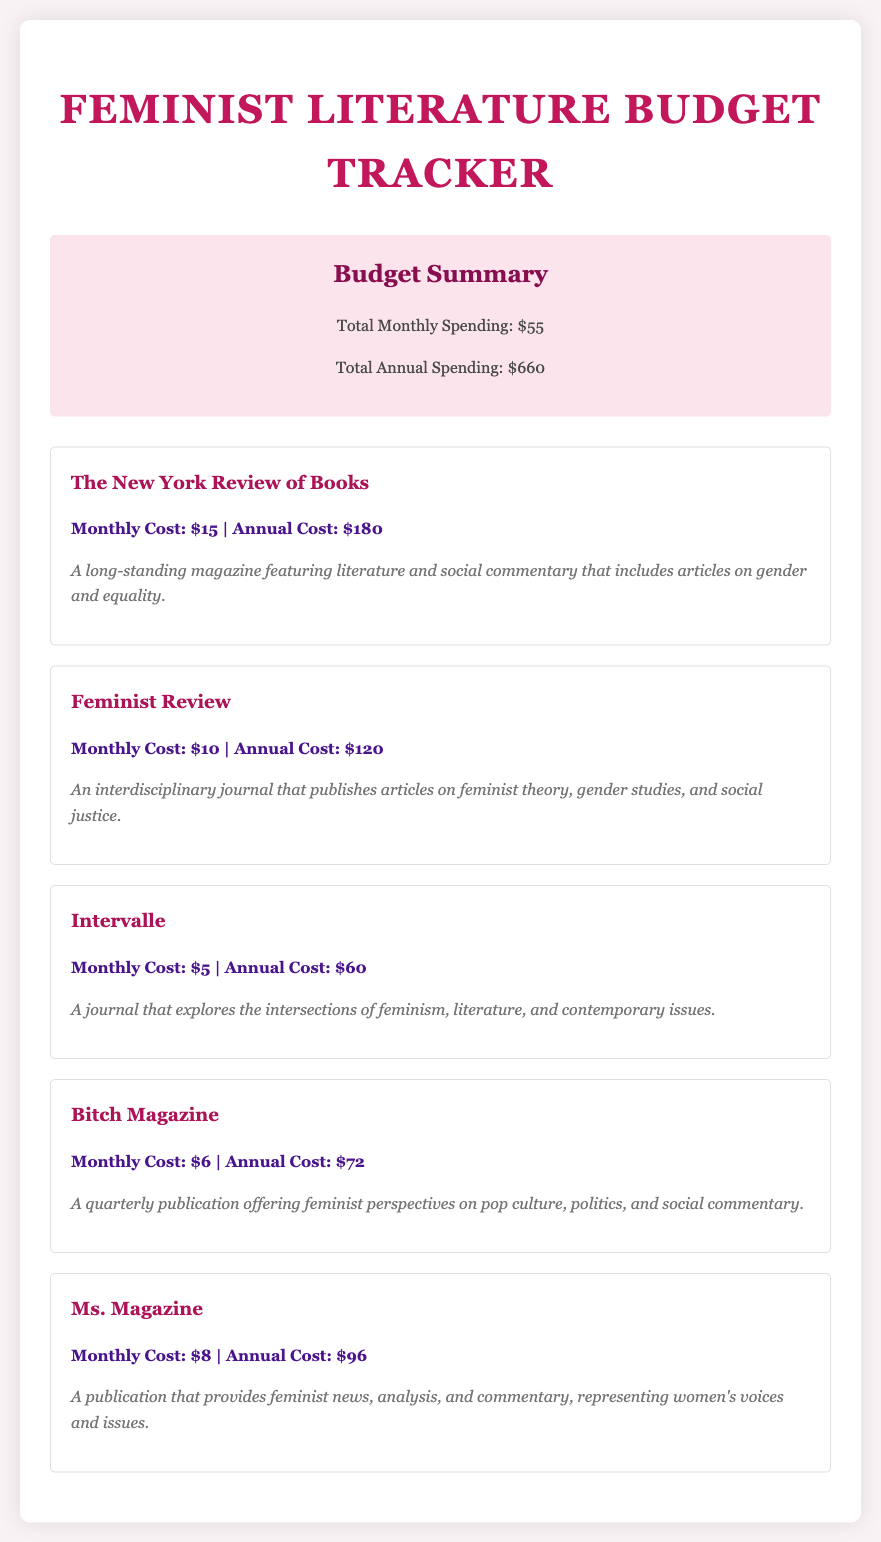What is the total monthly spending? The total monthly spending is presented in the budget summary section, which states it as $55.
Answer: $55 What is the annual cost for "Bitch Magazine"? The annual cost is listed directly under "Bitch Magazine," which is $72.
Answer: $72 How many subscriptions are listed? The total number of subscriptions can be counted from the document, which mentions five different ones.
Answer: 5 What is the monthly cost of "Feminist Review"? The monthly cost is stated explicitly for "Feminist Review" as $10.
Answer: $10 What is the total annual spending? The total annual spending is provided in the budget summary, amounting to $660.
Answer: $660 Which subscription has the lowest monthly cost? By comparing the monthly costs listed, "Intervalle" has the lowest at $5.
Answer: Intervalle What type of publication is "Ms. Magazine"? The document describes "Ms. Magazine" as a publication providing feminist news and analysis.
Answer: Feminist news What is the cost of "The New York Review of Books"? The costs are specified at $15 monthly and $180 annually for "The New York Review of Books."
Answer: $15 monthly, $180 annually What color is the summary background? The summary section background color is described within the document as light pink.
Answer: Light pink 